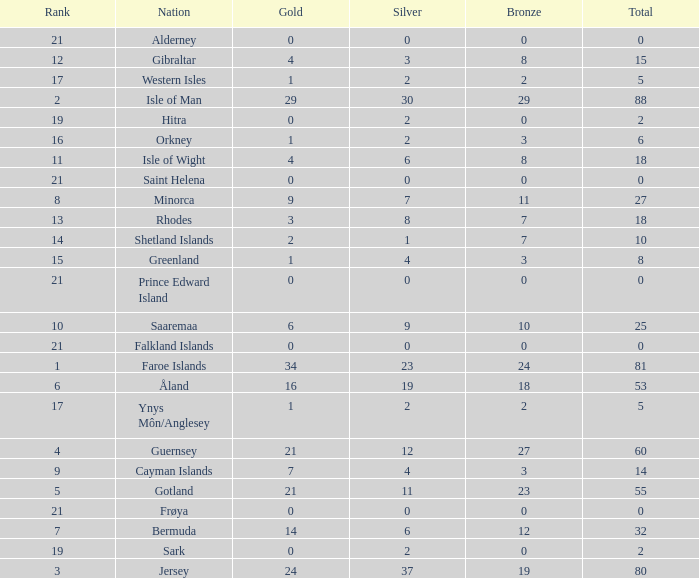How many Silver medals were won in total by all those with more than 3 bronze and exactly 16 gold? 19.0. 